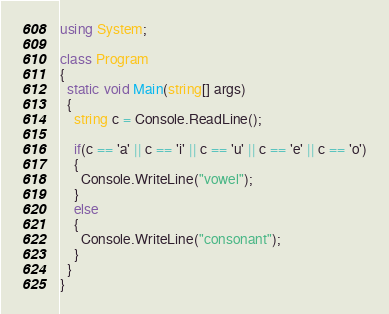Convert code to text. <code><loc_0><loc_0><loc_500><loc_500><_C#_>using System;
 
class Program
{
  static void Main(string[] args)
  {
    string c = Console.ReadLine();
    
    if(c == 'a' || c == 'i' || c == 'u' || c == 'e' || c == 'o')
    {
      Console.WriteLine("vowel");
    }
    else
    {
      Console.WriteLine("consonant");
    }
  }
}</code> 